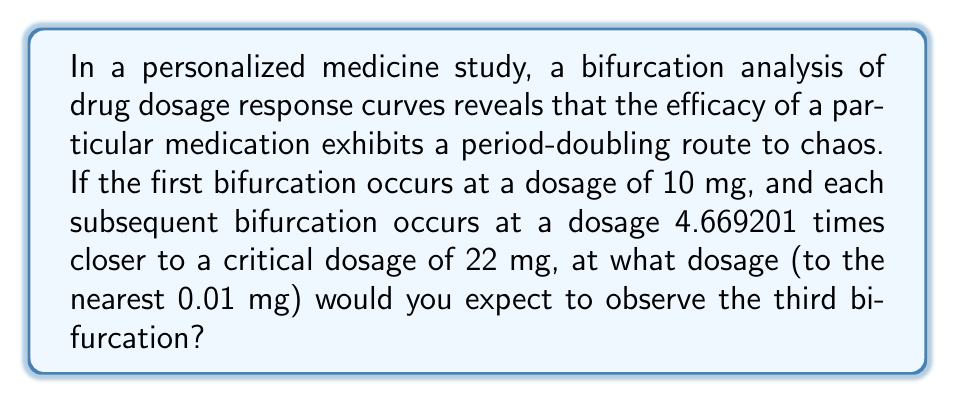Teach me how to tackle this problem. To solve this problem, we'll follow these steps:

1) Let's define our variables:
   $D_0$ = Initial dosage (first bifurcation) = 10 mg
   $D_c$ = Critical dosage = 22 mg
   $\delta$ = Feigenbaum constant ≈ 4.669201

2) The distance between bifurcations follows a geometric sequence with ratio $1/\delta$. Let's call the dosage at the nth bifurcation $D_n$. We can express this as:

   $D_n - D_{n-1} = \frac{D_c - D_{n-1}}{\delta}$

3) We need to find $D_3$. Let's start by finding $D_1$ and $D_2$:

   For $D_1$ (first bifurcation):
   $D_1 - D_0 = \frac{D_c - D_0}{\delta}$
   $D_1 - 10 = \frac{22 - 10}{4.669201}$
   $D_1 = 10 + \frac{12}{4.669201} ≈ 12.57$ mg

   For $D_2$ (second bifurcation):
   $D_2 - D_1 = \frac{D_c - D_1}{\delta}$
   $D_2 - 12.57 = \frac{22 - 12.57}{4.669201}$
   $D_2 ≈ 14.56$ mg

4) Now for $D_3$ (third bifurcation):
   $D_3 - D_2 = \frac{D_c - D_2}{\delta}$
   $D_3 - 14.56 = \frac{22 - 14.56}{4.669201}$
   $D_3 ≈ 16.09$ mg

5) Rounding to the nearest 0.01 mg gives us 16.09 mg.
Answer: 16.09 mg 